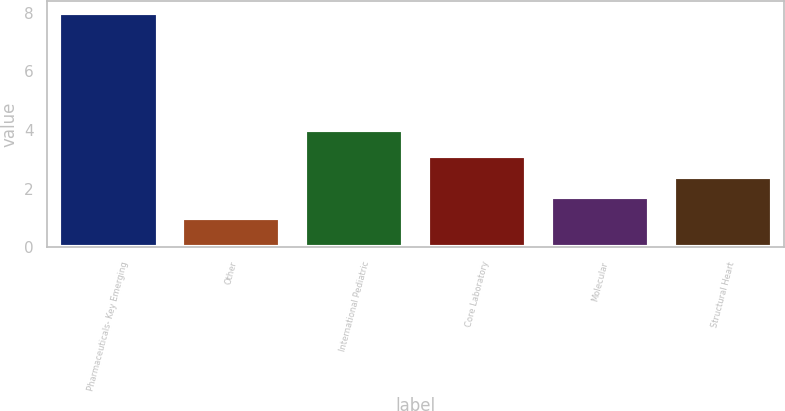<chart> <loc_0><loc_0><loc_500><loc_500><bar_chart><fcel>Pharmaceuticals- Key Emerging<fcel>Other<fcel>International Pediatric<fcel>Core Laboratory<fcel>Molecular<fcel>Structural Heart<nl><fcel>8<fcel>1<fcel>4<fcel>3.1<fcel>1.7<fcel>2.4<nl></chart> 